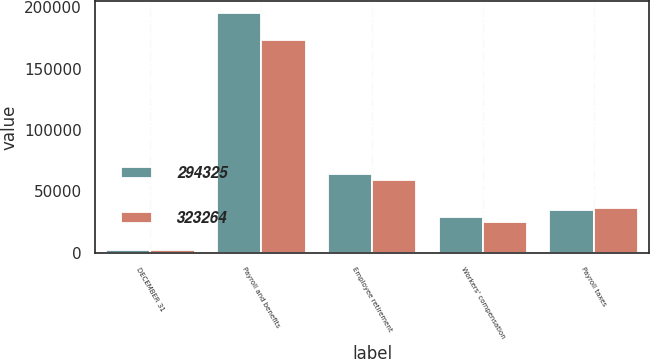Convert chart to OTSL. <chart><loc_0><loc_0><loc_500><loc_500><stacked_bar_chart><ecel><fcel>DECEMBER 31<fcel>Payroll and benefits<fcel>Employee retirement<fcel>Workers' compensation<fcel>Payroll taxes<nl><fcel>294325<fcel>2007<fcel>195383<fcel>64049<fcel>28996<fcel>34836<nl><fcel>323264<fcel>2006<fcel>173307<fcel>59129<fcel>24933<fcel>36956<nl></chart> 